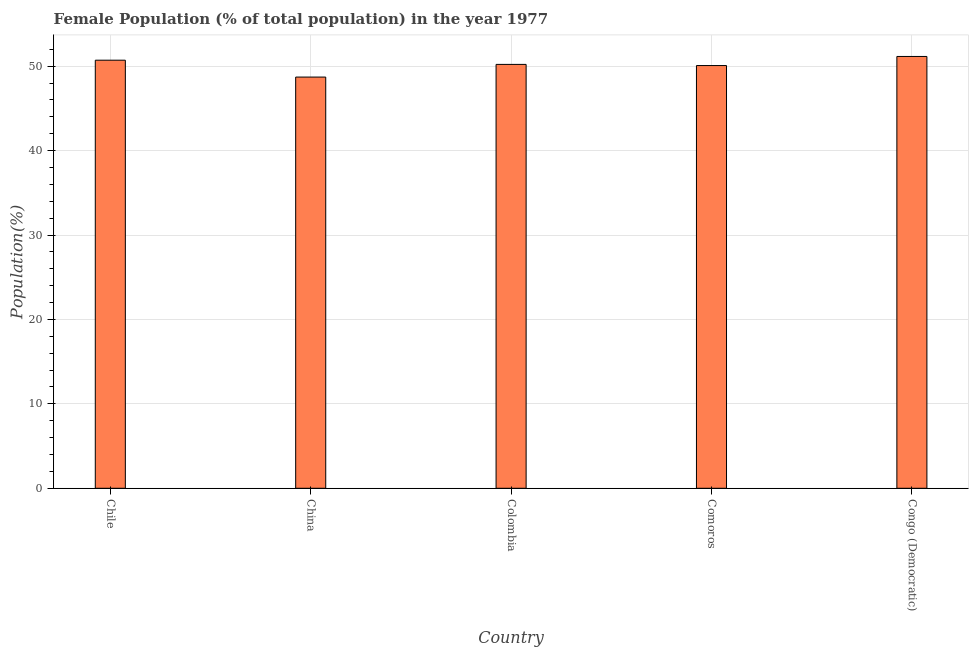Does the graph contain any zero values?
Your answer should be compact. No. What is the title of the graph?
Your response must be concise. Female Population (% of total population) in the year 1977. What is the label or title of the Y-axis?
Offer a terse response. Population(%). What is the female population in Chile?
Give a very brief answer. 50.71. Across all countries, what is the maximum female population?
Make the answer very short. 51.16. Across all countries, what is the minimum female population?
Provide a succinct answer. 48.72. In which country was the female population maximum?
Give a very brief answer. Congo (Democratic). What is the sum of the female population?
Your response must be concise. 250.88. What is the difference between the female population in China and Congo (Democratic)?
Your answer should be compact. -2.44. What is the average female population per country?
Your response must be concise. 50.18. What is the median female population?
Make the answer very short. 50.22. What is the ratio of the female population in Chile to that in Comoros?
Offer a very short reply. 1.01. Is the difference between the female population in Colombia and Congo (Democratic) greater than the difference between any two countries?
Offer a terse response. No. What is the difference between the highest and the second highest female population?
Your response must be concise. 0.44. What is the difference between the highest and the lowest female population?
Your answer should be compact. 2.44. In how many countries, is the female population greater than the average female population taken over all countries?
Offer a very short reply. 3. How many bars are there?
Your response must be concise. 5. Are all the bars in the graph horizontal?
Keep it short and to the point. No. Are the values on the major ticks of Y-axis written in scientific E-notation?
Your response must be concise. No. What is the Population(%) in Chile?
Offer a terse response. 50.71. What is the Population(%) in China?
Give a very brief answer. 48.72. What is the Population(%) in Colombia?
Give a very brief answer. 50.22. What is the Population(%) of Comoros?
Make the answer very short. 50.08. What is the Population(%) of Congo (Democratic)?
Your answer should be compact. 51.16. What is the difference between the Population(%) in Chile and China?
Offer a terse response. 2. What is the difference between the Population(%) in Chile and Colombia?
Ensure brevity in your answer.  0.5. What is the difference between the Population(%) in Chile and Comoros?
Provide a short and direct response. 0.64. What is the difference between the Population(%) in Chile and Congo (Democratic)?
Provide a short and direct response. -0.44. What is the difference between the Population(%) in China and Colombia?
Your answer should be compact. -1.5. What is the difference between the Population(%) in China and Comoros?
Ensure brevity in your answer.  -1.36. What is the difference between the Population(%) in China and Congo (Democratic)?
Your answer should be compact. -2.44. What is the difference between the Population(%) in Colombia and Comoros?
Offer a very short reply. 0.14. What is the difference between the Population(%) in Colombia and Congo (Democratic)?
Offer a very short reply. -0.94. What is the difference between the Population(%) in Comoros and Congo (Democratic)?
Offer a terse response. -1.08. What is the ratio of the Population(%) in Chile to that in China?
Make the answer very short. 1.04. What is the ratio of the Population(%) in Chile to that in Colombia?
Make the answer very short. 1.01. What is the ratio of the Population(%) in China to that in Comoros?
Offer a very short reply. 0.97. What is the ratio of the Population(%) in China to that in Congo (Democratic)?
Ensure brevity in your answer.  0.95. What is the ratio of the Population(%) in Colombia to that in Congo (Democratic)?
Your answer should be compact. 0.98. What is the ratio of the Population(%) in Comoros to that in Congo (Democratic)?
Make the answer very short. 0.98. 